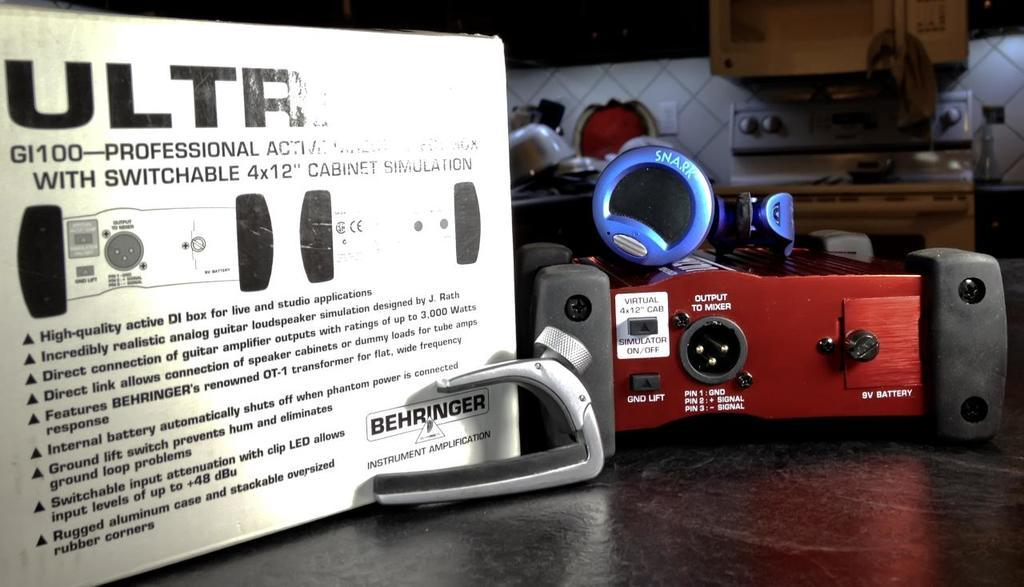<image>
Present a compact description of the photo's key features. A white box for a device made by Behringer sits on a darkly colored wooden table. 